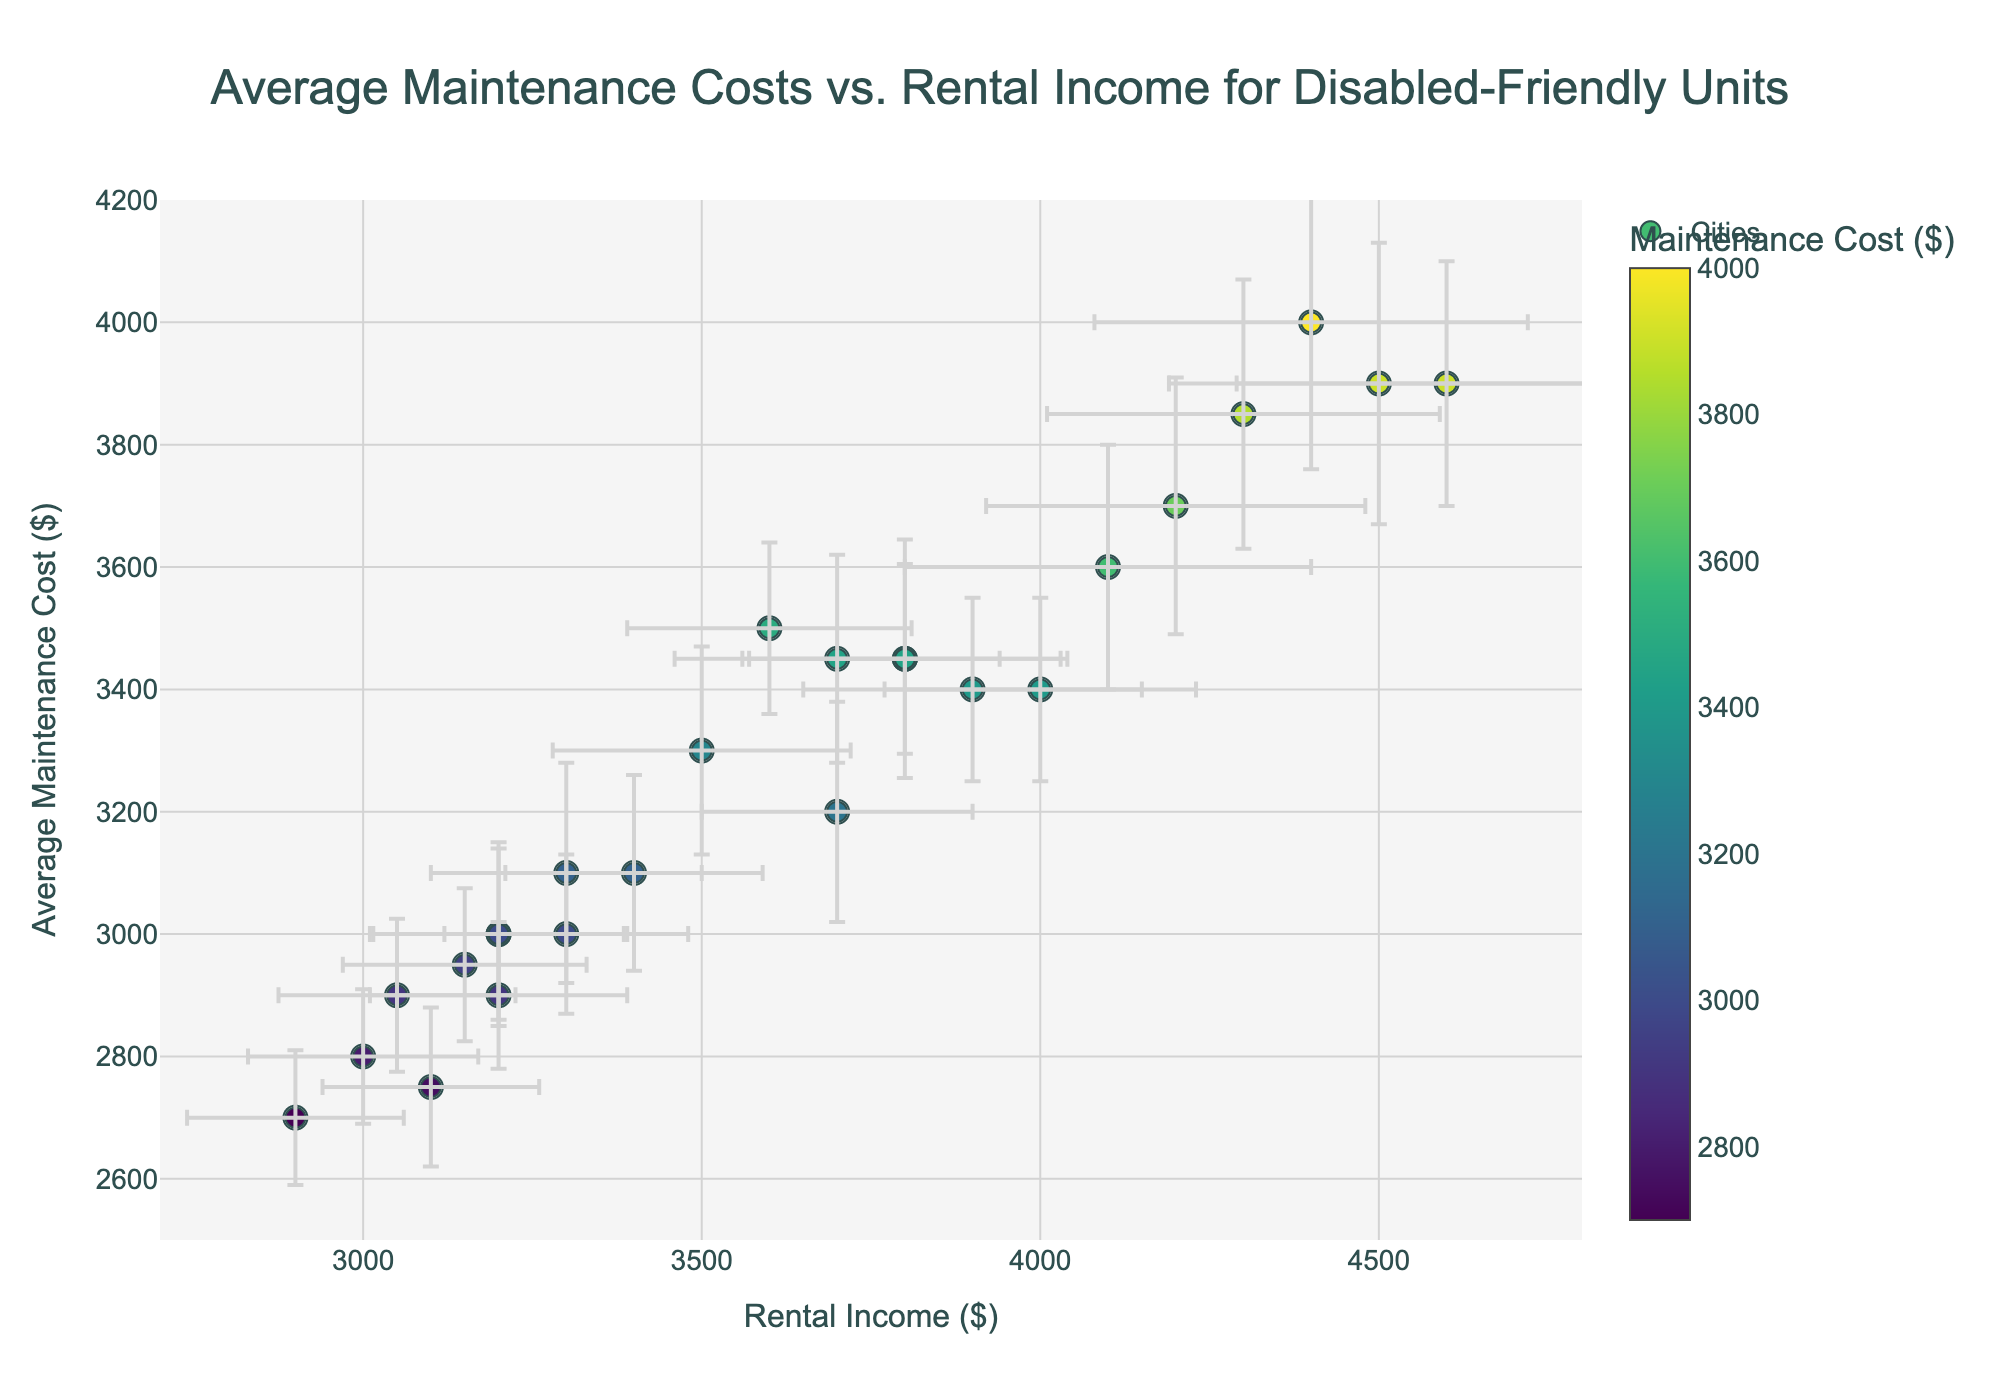What's the title of the figure? The title is shown at the top of the plot and highlights the main topic of the visualization. The title is "Average Maintenance Costs vs. Rental Income for Disabled-Friendly Units."
Answer: Average Maintenance Costs vs. Rental Income for Disabled-Friendly Units How many cities are represented in the figure? Each data point corresponds to a different city, and each data point is labeled with the city name. There are 25 cities listed in the data.
Answer: 25 What's the range of rental incomes shown on the x-axis? The x-axis represents rental income and has a defined range from around $2700 to $4800, as indicated by the axis labels and ticks.
Answer: 2700 to 4800 dollars Which city has the highest average maintenance cost? The point representing the city with the highest y-value on the plot indicates the highest average maintenance cost. According to the y-axis, San Francisco has the highest average maintenance cost.
Answer: San Francisco Are there any cities with rental income exactly at $3500? Point positions on the x-axis represent rental incomes. By examining this, Houston is at $3500 rental income.
Answer: Houston Which city has the lowest rental income? The city with the data point furthest to the left on the x-axis has the lowest rental income. This is Columbus at $3000.
Answer: Columbus What is the average maintenance cost for Boston? Points are labeled by city, and you can identify Boston's position on the plot, which aligns with the y-axis value of $3900.
Answer: 3900 dollars How does the rental income for Seattle compare to San Francisco? Determine Seattle's and San Francisco's positions on the x-axis. Seattle's rental income ($4300) is less than San Francisco's rental income ($4500).
Answer: Seattle is less than San Francisco Which city exhibits the largest error in maintenance cost? Error bars represent the error in maintenance cost. The city with the largest vertical error bar is Boston.
Answer: Boston Between New York and Chicago, which city has a higher rental income? Comparing the positions of New York and Chicago on the x-axis, New York has a higher rental income ($4100) than Chicago ($3700).
Answer: New York 